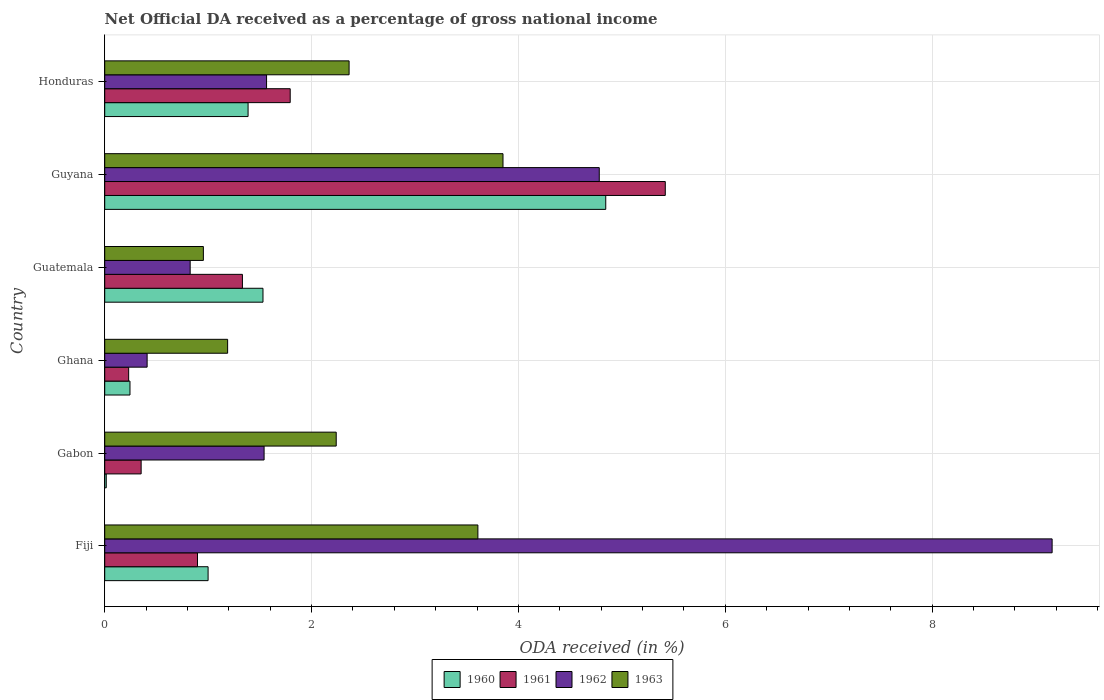How many groups of bars are there?
Offer a very short reply. 6. Are the number of bars per tick equal to the number of legend labels?
Give a very brief answer. Yes. Are the number of bars on each tick of the Y-axis equal?
Offer a very short reply. Yes. How many bars are there on the 5th tick from the top?
Give a very brief answer. 4. How many bars are there on the 2nd tick from the bottom?
Give a very brief answer. 4. What is the net official DA received in 1962 in Guyana?
Your answer should be compact. 4.78. Across all countries, what is the maximum net official DA received in 1963?
Your response must be concise. 3.85. Across all countries, what is the minimum net official DA received in 1962?
Keep it short and to the point. 0.41. In which country was the net official DA received in 1962 maximum?
Your answer should be compact. Fiji. In which country was the net official DA received in 1963 minimum?
Provide a succinct answer. Guatemala. What is the total net official DA received in 1963 in the graph?
Make the answer very short. 14.2. What is the difference between the net official DA received in 1960 in Gabon and that in Guatemala?
Your answer should be very brief. -1.52. What is the difference between the net official DA received in 1962 in Guyana and the net official DA received in 1961 in Honduras?
Give a very brief answer. 2.99. What is the average net official DA received in 1963 per country?
Offer a very short reply. 2.37. What is the difference between the net official DA received in 1962 and net official DA received in 1963 in Guyana?
Provide a short and direct response. 0.93. In how many countries, is the net official DA received in 1960 greater than 5.6 %?
Your answer should be compact. 0. What is the ratio of the net official DA received in 1963 in Gabon to that in Ghana?
Provide a succinct answer. 1.88. Is the net official DA received in 1963 in Guatemala less than that in Honduras?
Ensure brevity in your answer.  Yes. What is the difference between the highest and the second highest net official DA received in 1961?
Offer a terse response. 3.63. What is the difference between the highest and the lowest net official DA received in 1963?
Your answer should be very brief. 2.9. Is it the case that in every country, the sum of the net official DA received in 1962 and net official DA received in 1960 is greater than the sum of net official DA received in 1963 and net official DA received in 1961?
Your response must be concise. No. What does the 1st bar from the top in Guyana represents?
Your response must be concise. 1963. What does the 2nd bar from the bottom in Ghana represents?
Offer a terse response. 1961. Is it the case that in every country, the sum of the net official DA received in 1963 and net official DA received in 1960 is greater than the net official DA received in 1962?
Give a very brief answer. No. How many bars are there?
Provide a succinct answer. 24. How many legend labels are there?
Make the answer very short. 4. What is the title of the graph?
Provide a short and direct response. Net Official DA received as a percentage of gross national income. What is the label or title of the X-axis?
Keep it short and to the point. ODA received (in %). What is the ODA received (in %) in 1960 in Fiji?
Your answer should be compact. 1. What is the ODA received (in %) of 1961 in Fiji?
Make the answer very short. 0.9. What is the ODA received (in %) of 1962 in Fiji?
Offer a very short reply. 9.16. What is the ODA received (in %) in 1963 in Fiji?
Ensure brevity in your answer.  3.61. What is the ODA received (in %) in 1960 in Gabon?
Provide a succinct answer. 0.01. What is the ODA received (in %) of 1961 in Gabon?
Keep it short and to the point. 0.35. What is the ODA received (in %) of 1962 in Gabon?
Your response must be concise. 1.54. What is the ODA received (in %) in 1963 in Gabon?
Your answer should be compact. 2.24. What is the ODA received (in %) of 1960 in Ghana?
Your answer should be compact. 0.24. What is the ODA received (in %) in 1961 in Ghana?
Provide a short and direct response. 0.23. What is the ODA received (in %) in 1962 in Ghana?
Ensure brevity in your answer.  0.41. What is the ODA received (in %) in 1963 in Ghana?
Make the answer very short. 1.19. What is the ODA received (in %) of 1960 in Guatemala?
Provide a short and direct response. 1.53. What is the ODA received (in %) of 1961 in Guatemala?
Keep it short and to the point. 1.33. What is the ODA received (in %) in 1962 in Guatemala?
Your answer should be very brief. 0.83. What is the ODA received (in %) in 1963 in Guatemala?
Ensure brevity in your answer.  0.95. What is the ODA received (in %) in 1960 in Guyana?
Make the answer very short. 4.84. What is the ODA received (in %) of 1961 in Guyana?
Offer a very short reply. 5.42. What is the ODA received (in %) of 1962 in Guyana?
Your response must be concise. 4.78. What is the ODA received (in %) of 1963 in Guyana?
Your answer should be compact. 3.85. What is the ODA received (in %) in 1960 in Honduras?
Give a very brief answer. 1.39. What is the ODA received (in %) of 1961 in Honduras?
Keep it short and to the point. 1.79. What is the ODA received (in %) of 1962 in Honduras?
Give a very brief answer. 1.56. What is the ODA received (in %) in 1963 in Honduras?
Keep it short and to the point. 2.36. Across all countries, what is the maximum ODA received (in %) of 1960?
Offer a very short reply. 4.84. Across all countries, what is the maximum ODA received (in %) in 1961?
Provide a succinct answer. 5.42. Across all countries, what is the maximum ODA received (in %) in 1962?
Make the answer very short. 9.16. Across all countries, what is the maximum ODA received (in %) of 1963?
Ensure brevity in your answer.  3.85. Across all countries, what is the minimum ODA received (in %) in 1960?
Give a very brief answer. 0.01. Across all countries, what is the minimum ODA received (in %) of 1961?
Your response must be concise. 0.23. Across all countries, what is the minimum ODA received (in %) of 1962?
Make the answer very short. 0.41. Across all countries, what is the minimum ODA received (in %) in 1963?
Your answer should be compact. 0.95. What is the total ODA received (in %) of 1960 in the graph?
Make the answer very short. 9.02. What is the total ODA received (in %) in 1961 in the graph?
Your response must be concise. 10.03. What is the total ODA received (in %) of 1962 in the graph?
Your answer should be compact. 18.28. What is the total ODA received (in %) of 1963 in the graph?
Offer a very short reply. 14.2. What is the difference between the ODA received (in %) in 1960 in Fiji and that in Gabon?
Provide a short and direct response. 0.98. What is the difference between the ODA received (in %) of 1961 in Fiji and that in Gabon?
Provide a succinct answer. 0.55. What is the difference between the ODA received (in %) in 1962 in Fiji and that in Gabon?
Provide a succinct answer. 7.62. What is the difference between the ODA received (in %) of 1963 in Fiji and that in Gabon?
Offer a terse response. 1.37. What is the difference between the ODA received (in %) of 1960 in Fiji and that in Ghana?
Offer a very short reply. 0.76. What is the difference between the ODA received (in %) of 1961 in Fiji and that in Ghana?
Provide a succinct answer. 0.67. What is the difference between the ODA received (in %) of 1962 in Fiji and that in Ghana?
Provide a short and direct response. 8.75. What is the difference between the ODA received (in %) in 1963 in Fiji and that in Ghana?
Your answer should be compact. 2.42. What is the difference between the ODA received (in %) in 1960 in Fiji and that in Guatemala?
Provide a short and direct response. -0.53. What is the difference between the ODA received (in %) in 1961 in Fiji and that in Guatemala?
Make the answer very short. -0.43. What is the difference between the ODA received (in %) of 1962 in Fiji and that in Guatemala?
Offer a terse response. 8.33. What is the difference between the ODA received (in %) of 1963 in Fiji and that in Guatemala?
Your answer should be compact. 2.65. What is the difference between the ODA received (in %) in 1960 in Fiji and that in Guyana?
Offer a very short reply. -3.84. What is the difference between the ODA received (in %) of 1961 in Fiji and that in Guyana?
Provide a short and direct response. -4.52. What is the difference between the ODA received (in %) in 1962 in Fiji and that in Guyana?
Provide a short and direct response. 4.38. What is the difference between the ODA received (in %) of 1963 in Fiji and that in Guyana?
Offer a terse response. -0.24. What is the difference between the ODA received (in %) of 1960 in Fiji and that in Honduras?
Your answer should be compact. -0.39. What is the difference between the ODA received (in %) in 1961 in Fiji and that in Honduras?
Provide a short and direct response. -0.9. What is the difference between the ODA received (in %) in 1962 in Fiji and that in Honduras?
Offer a very short reply. 7.59. What is the difference between the ODA received (in %) in 1963 in Fiji and that in Honduras?
Your answer should be very brief. 1.25. What is the difference between the ODA received (in %) in 1960 in Gabon and that in Ghana?
Provide a short and direct response. -0.23. What is the difference between the ODA received (in %) in 1961 in Gabon and that in Ghana?
Your answer should be very brief. 0.12. What is the difference between the ODA received (in %) of 1962 in Gabon and that in Ghana?
Ensure brevity in your answer.  1.13. What is the difference between the ODA received (in %) of 1963 in Gabon and that in Ghana?
Give a very brief answer. 1.05. What is the difference between the ODA received (in %) of 1960 in Gabon and that in Guatemala?
Keep it short and to the point. -1.52. What is the difference between the ODA received (in %) of 1961 in Gabon and that in Guatemala?
Your answer should be very brief. -0.98. What is the difference between the ODA received (in %) in 1962 in Gabon and that in Guatemala?
Offer a very short reply. 0.71. What is the difference between the ODA received (in %) in 1963 in Gabon and that in Guatemala?
Provide a succinct answer. 1.28. What is the difference between the ODA received (in %) in 1960 in Gabon and that in Guyana?
Provide a short and direct response. -4.83. What is the difference between the ODA received (in %) in 1961 in Gabon and that in Guyana?
Your answer should be compact. -5.07. What is the difference between the ODA received (in %) in 1962 in Gabon and that in Guyana?
Your answer should be compact. -3.24. What is the difference between the ODA received (in %) of 1963 in Gabon and that in Guyana?
Keep it short and to the point. -1.61. What is the difference between the ODA received (in %) of 1960 in Gabon and that in Honduras?
Provide a succinct answer. -1.37. What is the difference between the ODA received (in %) of 1961 in Gabon and that in Honduras?
Offer a very short reply. -1.44. What is the difference between the ODA received (in %) in 1962 in Gabon and that in Honduras?
Provide a short and direct response. -0.02. What is the difference between the ODA received (in %) of 1963 in Gabon and that in Honduras?
Your response must be concise. -0.12. What is the difference between the ODA received (in %) of 1960 in Ghana and that in Guatemala?
Keep it short and to the point. -1.29. What is the difference between the ODA received (in %) in 1961 in Ghana and that in Guatemala?
Your answer should be very brief. -1.1. What is the difference between the ODA received (in %) in 1962 in Ghana and that in Guatemala?
Offer a very short reply. -0.42. What is the difference between the ODA received (in %) in 1963 in Ghana and that in Guatemala?
Keep it short and to the point. 0.23. What is the difference between the ODA received (in %) in 1960 in Ghana and that in Guyana?
Offer a terse response. -4.6. What is the difference between the ODA received (in %) of 1961 in Ghana and that in Guyana?
Provide a short and direct response. -5.19. What is the difference between the ODA received (in %) of 1962 in Ghana and that in Guyana?
Your response must be concise. -4.37. What is the difference between the ODA received (in %) of 1963 in Ghana and that in Guyana?
Keep it short and to the point. -2.66. What is the difference between the ODA received (in %) of 1960 in Ghana and that in Honduras?
Provide a succinct answer. -1.14. What is the difference between the ODA received (in %) of 1961 in Ghana and that in Honduras?
Keep it short and to the point. -1.56. What is the difference between the ODA received (in %) in 1962 in Ghana and that in Honduras?
Provide a succinct answer. -1.15. What is the difference between the ODA received (in %) of 1963 in Ghana and that in Honduras?
Give a very brief answer. -1.17. What is the difference between the ODA received (in %) of 1960 in Guatemala and that in Guyana?
Provide a succinct answer. -3.31. What is the difference between the ODA received (in %) in 1961 in Guatemala and that in Guyana?
Provide a succinct answer. -4.09. What is the difference between the ODA received (in %) of 1962 in Guatemala and that in Guyana?
Your answer should be compact. -3.96. What is the difference between the ODA received (in %) of 1963 in Guatemala and that in Guyana?
Offer a terse response. -2.9. What is the difference between the ODA received (in %) in 1960 in Guatemala and that in Honduras?
Your answer should be very brief. 0.14. What is the difference between the ODA received (in %) of 1961 in Guatemala and that in Honduras?
Your response must be concise. -0.46. What is the difference between the ODA received (in %) of 1962 in Guatemala and that in Honduras?
Offer a very short reply. -0.74. What is the difference between the ODA received (in %) in 1963 in Guatemala and that in Honduras?
Give a very brief answer. -1.41. What is the difference between the ODA received (in %) in 1960 in Guyana and that in Honduras?
Your answer should be very brief. 3.46. What is the difference between the ODA received (in %) in 1961 in Guyana and that in Honduras?
Ensure brevity in your answer.  3.63. What is the difference between the ODA received (in %) of 1962 in Guyana and that in Honduras?
Make the answer very short. 3.22. What is the difference between the ODA received (in %) in 1963 in Guyana and that in Honduras?
Your answer should be very brief. 1.49. What is the difference between the ODA received (in %) in 1960 in Fiji and the ODA received (in %) in 1961 in Gabon?
Your answer should be compact. 0.65. What is the difference between the ODA received (in %) in 1960 in Fiji and the ODA received (in %) in 1962 in Gabon?
Ensure brevity in your answer.  -0.54. What is the difference between the ODA received (in %) in 1960 in Fiji and the ODA received (in %) in 1963 in Gabon?
Your answer should be compact. -1.24. What is the difference between the ODA received (in %) in 1961 in Fiji and the ODA received (in %) in 1962 in Gabon?
Offer a very short reply. -0.64. What is the difference between the ODA received (in %) of 1961 in Fiji and the ODA received (in %) of 1963 in Gabon?
Provide a short and direct response. -1.34. What is the difference between the ODA received (in %) in 1962 in Fiji and the ODA received (in %) in 1963 in Gabon?
Ensure brevity in your answer.  6.92. What is the difference between the ODA received (in %) of 1960 in Fiji and the ODA received (in %) of 1961 in Ghana?
Make the answer very short. 0.77. What is the difference between the ODA received (in %) in 1960 in Fiji and the ODA received (in %) in 1962 in Ghana?
Give a very brief answer. 0.59. What is the difference between the ODA received (in %) of 1960 in Fiji and the ODA received (in %) of 1963 in Ghana?
Keep it short and to the point. -0.19. What is the difference between the ODA received (in %) of 1961 in Fiji and the ODA received (in %) of 1962 in Ghana?
Ensure brevity in your answer.  0.49. What is the difference between the ODA received (in %) of 1961 in Fiji and the ODA received (in %) of 1963 in Ghana?
Offer a terse response. -0.29. What is the difference between the ODA received (in %) of 1962 in Fiji and the ODA received (in %) of 1963 in Ghana?
Make the answer very short. 7.97. What is the difference between the ODA received (in %) in 1960 in Fiji and the ODA received (in %) in 1961 in Guatemala?
Keep it short and to the point. -0.33. What is the difference between the ODA received (in %) of 1960 in Fiji and the ODA received (in %) of 1962 in Guatemala?
Provide a succinct answer. 0.17. What is the difference between the ODA received (in %) in 1960 in Fiji and the ODA received (in %) in 1963 in Guatemala?
Offer a terse response. 0.05. What is the difference between the ODA received (in %) of 1961 in Fiji and the ODA received (in %) of 1962 in Guatemala?
Provide a short and direct response. 0.07. What is the difference between the ODA received (in %) of 1961 in Fiji and the ODA received (in %) of 1963 in Guatemala?
Your response must be concise. -0.06. What is the difference between the ODA received (in %) in 1962 in Fiji and the ODA received (in %) in 1963 in Guatemala?
Your answer should be compact. 8.21. What is the difference between the ODA received (in %) of 1960 in Fiji and the ODA received (in %) of 1961 in Guyana?
Offer a terse response. -4.42. What is the difference between the ODA received (in %) in 1960 in Fiji and the ODA received (in %) in 1962 in Guyana?
Provide a succinct answer. -3.78. What is the difference between the ODA received (in %) in 1960 in Fiji and the ODA received (in %) in 1963 in Guyana?
Provide a short and direct response. -2.85. What is the difference between the ODA received (in %) in 1961 in Fiji and the ODA received (in %) in 1962 in Guyana?
Your answer should be very brief. -3.88. What is the difference between the ODA received (in %) in 1961 in Fiji and the ODA received (in %) in 1963 in Guyana?
Give a very brief answer. -2.95. What is the difference between the ODA received (in %) of 1962 in Fiji and the ODA received (in %) of 1963 in Guyana?
Give a very brief answer. 5.31. What is the difference between the ODA received (in %) in 1960 in Fiji and the ODA received (in %) in 1961 in Honduras?
Make the answer very short. -0.79. What is the difference between the ODA received (in %) in 1960 in Fiji and the ODA received (in %) in 1962 in Honduras?
Offer a very short reply. -0.57. What is the difference between the ODA received (in %) in 1960 in Fiji and the ODA received (in %) in 1963 in Honduras?
Your answer should be very brief. -1.36. What is the difference between the ODA received (in %) of 1961 in Fiji and the ODA received (in %) of 1962 in Honduras?
Provide a short and direct response. -0.67. What is the difference between the ODA received (in %) in 1961 in Fiji and the ODA received (in %) in 1963 in Honduras?
Offer a terse response. -1.47. What is the difference between the ODA received (in %) in 1962 in Fiji and the ODA received (in %) in 1963 in Honduras?
Ensure brevity in your answer.  6.8. What is the difference between the ODA received (in %) in 1960 in Gabon and the ODA received (in %) in 1961 in Ghana?
Give a very brief answer. -0.22. What is the difference between the ODA received (in %) of 1960 in Gabon and the ODA received (in %) of 1962 in Ghana?
Offer a very short reply. -0.4. What is the difference between the ODA received (in %) of 1960 in Gabon and the ODA received (in %) of 1963 in Ghana?
Offer a terse response. -1.17. What is the difference between the ODA received (in %) of 1961 in Gabon and the ODA received (in %) of 1962 in Ghana?
Your answer should be very brief. -0.06. What is the difference between the ODA received (in %) in 1961 in Gabon and the ODA received (in %) in 1963 in Ghana?
Your answer should be very brief. -0.84. What is the difference between the ODA received (in %) in 1962 in Gabon and the ODA received (in %) in 1963 in Ghana?
Offer a very short reply. 0.35. What is the difference between the ODA received (in %) of 1960 in Gabon and the ODA received (in %) of 1961 in Guatemala?
Keep it short and to the point. -1.32. What is the difference between the ODA received (in %) of 1960 in Gabon and the ODA received (in %) of 1962 in Guatemala?
Offer a terse response. -0.81. What is the difference between the ODA received (in %) in 1960 in Gabon and the ODA received (in %) in 1963 in Guatemala?
Give a very brief answer. -0.94. What is the difference between the ODA received (in %) in 1961 in Gabon and the ODA received (in %) in 1962 in Guatemala?
Offer a terse response. -0.47. What is the difference between the ODA received (in %) in 1961 in Gabon and the ODA received (in %) in 1963 in Guatemala?
Provide a succinct answer. -0.6. What is the difference between the ODA received (in %) in 1962 in Gabon and the ODA received (in %) in 1963 in Guatemala?
Provide a succinct answer. 0.59. What is the difference between the ODA received (in %) in 1960 in Gabon and the ODA received (in %) in 1961 in Guyana?
Your answer should be very brief. -5.4. What is the difference between the ODA received (in %) of 1960 in Gabon and the ODA received (in %) of 1962 in Guyana?
Offer a terse response. -4.77. What is the difference between the ODA received (in %) in 1960 in Gabon and the ODA received (in %) in 1963 in Guyana?
Your answer should be compact. -3.84. What is the difference between the ODA received (in %) of 1961 in Gabon and the ODA received (in %) of 1962 in Guyana?
Provide a short and direct response. -4.43. What is the difference between the ODA received (in %) in 1961 in Gabon and the ODA received (in %) in 1963 in Guyana?
Keep it short and to the point. -3.5. What is the difference between the ODA received (in %) of 1962 in Gabon and the ODA received (in %) of 1963 in Guyana?
Offer a terse response. -2.31. What is the difference between the ODA received (in %) in 1960 in Gabon and the ODA received (in %) in 1961 in Honduras?
Ensure brevity in your answer.  -1.78. What is the difference between the ODA received (in %) of 1960 in Gabon and the ODA received (in %) of 1962 in Honduras?
Your answer should be compact. -1.55. What is the difference between the ODA received (in %) in 1960 in Gabon and the ODA received (in %) in 1963 in Honduras?
Offer a very short reply. -2.35. What is the difference between the ODA received (in %) in 1961 in Gabon and the ODA received (in %) in 1962 in Honduras?
Provide a succinct answer. -1.21. What is the difference between the ODA received (in %) of 1961 in Gabon and the ODA received (in %) of 1963 in Honduras?
Give a very brief answer. -2.01. What is the difference between the ODA received (in %) of 1962 in Gabon and the ODA received (in %) of 1963 in Honduras?
Offer a terse response. -0.82. What is the difference between the ODA received (in %) in 1960 in Ghana and the ODA received (in %) in 1961 in Guatemala?
Give a very brief answer. -1.09. What is the difference between the ODA received (in %) of 1960 in Ghana and the ODA received (in %) of 1962 in Guatemala?
Make the answer very short. -0.58. What is the difference between the ODA received (in %) of 1960 in Ghana and the ODA received (in %) of 1963 in Guatemala?
Offer a terse response. -0.71. What is the difference between the ODA received (in %) of 1961 in Ghana and the ODA received (in %) of 1962 in Guatemala?
Provide a short and direct response. -0.59. What is the difference between the ODA received (in %) of 1961 in Ghana and the ODA received (in %) of 1963 in Guatemala?
Offer a terse response. -0.72. What is the difference between the ODA received (in %) in 1962 in Ghana and the ODA received (in %) in 1963 in Guatemala?
Provide a succinct answer. -0.54. What is the difference between the ODA received (in %) in 1960 in Ghana and the ODA received (in %) in 1961 in Guyana?
Offer a terse response. -5.18. What is the difference between the ODA received (in %) in 1960 in Ghana and the ODA received (in %) in 1962 in Guyana?
Make the answer very short. -4.54. What is the difference between the ODA received (in %) in 1960 in Ghana and the ODA received (in %) in 1963 in Guyana?
Your answer should be compact. -3.61. What is the difference between the ODA received (in %) in 1961 in Ghana and the ODA received (in %) in 1962 in Guyana?
Your response must be concise. -4.55. What is the difference between the ODA received (in %) of 1961 in Ghana and the ODA received (in %) of 1963 in Guyana?
Provide a short and direct response. -3.62. What is the difference between the ODA received (in %) of 1962 in Ghana and the ODA received (in %) of 1963 in Guyana?
Your answer should be very brief. -3.44. What is the difference between the ODA received (in %) in 1960 in Ghana and the ODA received (in %) in 1961 in Honduras?
Make the answer very short. -1.55. What is the difference between the ODA received (in %) in 1960 in Ghana and the ODA received (in %) in 1962 in Honduras?
Keep it short and to the point. -1.32. What is the difference between the ODA received (in %) of 1960 in Ghana and the ODA received (in %) of 1963 in Honduras?
Your answer should be compact. -2.12. What is the difference between the ODA received (in %) in 1961 in Ghana and the ODA received (in %) in 1962 in Honduras?
Provide a short and direct response. -1.33. What is the difference between the ODA received (in %) of 1961 in Ghana and the ODA received (in %) of 1963 in Honduras?
Your answer should be very brief. -2.13. What is the difference between the ODA received (in %) in 1962 in Ghana and the ODA received (in %) in 1963 in Honduras?
Your answer should be compact. -1.95. What is the difference between the ODA received (in %) in 1960 in Guatemala and the ODA received (in %) in 1961 in Guyana?
Offer a terse response. -3.89. What is the difference between the ODA received (in %) in 1960 in Guatemala and the ODA received (in %) in 1962 in Guyana?
Your answer should be very brief. -3.25. What is the difference between the ODA received (in %) of 1960 in Guatemala and the ODA received (in %) of 1963 in Guyana?
Your response must be concise. -2.32. What is the difference between the ODA received (in %) of 1961 in Guatemala and the ODA received (in %) of 1962 in Guyana?
Provide a succinct answer. -3.45. What is the difference between the ODA received (in %) in 1961 in Guatemala and the ODA received (in %) in 1963 in Guyana?
Offer a terse response. -2.52. What is the difference between the ODA received (in %) in 1962 in Guatemala and the ODA received (in %) in 1963 in Guyana?
Your answer should be compact. -3.02. What is the difference between the ODA received (in %) of 1960 in Guatemala and the ODA received (in %) of 1961 in Honduras?
Ensure brevity in your answer.  -0.26. What is the difference between the ODA received (in %) in 1960 in Guatemala and the ODA received (in %) in 1962 in Honduras?
Keep it short and to the point. -0.03. What is the difference between the ODA received (in %) in 1960 in Guatemala and the ODA received (in %) in 1963 in Honduras?
Make the answer very short. -0.83. What is the difference between the ODA received (in %) in 1961 in Guatemala and the ODA received (in %) in 1962 in Honduras?
Offer a terse response. -0.23. What is the difference between the ODA received (in %) of 1961 in Guatemala and the ODA received (in %) of 1963 in Honduras?
Provide a short and direct response. -1.03. What is the difference between the ODA received (in %) in 1962 in Guatemala and the ODA received (in %) in 1963 in Honduras?
Your response must be concise. -1.54. What is the difference between the ODA received (in %) of 1960 in Guyana and the ODA received (in %) of 1961 in Honduras?
Provide a short and direct response. 3.05. What is the difference between the ODA received (in %) in 1960 in Guyana and the ODA received (in %) in 1962 in Honduras?
Provide a short and direct response. 3.28. What is the difference between the ODA received (in %) in 1960 in Guyana and the ODA received (in %) in 1963 in Honduras?
Your answer should be very brief. 2.48. What is the difference between the ODA received (in %) in 1961 in Guyana and the ODA received (in %) in 1962 in Honduras?
Offer a very short reply. 3.85. What is the difference between the ODA received (in %) in 1961 in Guyana and the ODA received (in %) in 1963 in Honduras?
Your answer should be compact. 3.06. What is the difference between the ODA received (in %) of 1962 in Guyana and the ODA received (in %) of 1963 in Honduras?
Keep it short and to the point. 2.42. What is the average ODA received (in %) of 1960 per country?
Offer a very short reply. 1.5. What is the average ODA received (in %) in 1961 per country?
Your answer should be compact. 1.67. What is the average ODA received (in %) of 1962 per country?
Your answer should be compact. 3.05. What is the average ODA received (in %) of 1963 per country?
Make the answer very short. 2.37. What is the difference between the ODA received (in %) in 1960 and ODA received (in %) in 1961 in Fiji?
Ensure brevity in your answer.  0.1. What is the difference between the ODA received (in %) in 1960 and ODA received (in %) in 1962 in Fiji?
Offer a terse response. -8.16. What is the difference between the ODA received (in %) in 1960 and ODA received (in %) in 1963 in Fiji?
Your response must be concise. -2.61. What is the difference between the ODA received (in %) of 1961 and ODA received (in %) of 1962 in Fiji?
Offer a very short reply. -8.26. What is the difference between the ODA received (in %) of 1961 and ODA received (in %) of 1963 in Fiji?
Your response must be concise. -2.71. What is the difference between the ODA received (in %) in 1962 and ODA received (in %) in 1963 in Fiji?
Your response must be concise. 5.55. What is the difference between the ODA received (in %) in 1960 and ODA received (in %) in 1961 in Gabon?
Give a very brief answer. -0.34. What is the difference between the ODA received (in %) of 1960 and ODA received (in %) of 1962 in Gabon?
Provide a short and direct response. -1.53. What is the difference between the ODA received (in %) in 1960 and ODA received (in %) in 1963 in Gabon?
Make the answer very short. -2.22. What is the difference between the ODA received (in %) in 1961 and ODA received (in %) in 1962 in Gabon?
Make the answer very short. -1.19. What is the difference between the ODA received (in %) of 1961 and ODA received (in %) of 1963 in Gabon?
Your answer should be compact. -1.89. What is the difference between the ODA received (in %) of 1962 and ODA received (in %) of 1963 in Gabon?
Offer a terse response. -0.7. What is the difference between the ODA received (in %) of 1960 and ODA received (in %) of 1961 in Ghana?
Ensure brevity in your answer.  0.01. What is the difference between the ODA received (in %) of 1960 and ODA received (in %) of 1962 in Ghana?
Make the answer very short. -0.17. What is the difference between the ODA received (in %) in 1960 and ODA received (in %) in 1963 in Ghana?
Your answer should be very brief. -0.94. What is the difference between the ODA received (in %) in 1961 and ODA received (in %) in 1962 in Ghana?
Make the answer very short. -0.18. What is the difference between the ODA received (in %) of 1961 and ODA received (in %) of 1963 in Ghana?
Offer a terse response. -0.96. What is the difference between the ODA received (in %) in 1962 and ODA received (in %) in 1963 in Ghana?
Offer a terse response. -0.78. What is the difference between the ODA received (in %) in 1960 and ODA received (in %) in 1961 in Guatemala?
Offer a very short reply. 0.2. What is the difference between the ODA received (in %) in 1960 and ODA received (in %) in 1962 in Guatemala?
Keep it short and to the point. 0.7. What is the difference between the ODA received (in %) in 1960 and ODA received (in %) in 1963 in Guatemala?
Your answer should be compact. 0.58. What is the difference between the ODA received (in %) in 1961 and ODA received (in %) in 1962 in Guatemala?
Provide a short and direct response. 0.51. What is the difference between the ODA received (in %) in 1961 and ODA received (in %) in 1963 in Guatemala?
Make the answer very short. 0.38. What is the difference between the ODA received (in %) of 1962 and ODA received (in %) of 1963 in Guatemala?
Your answer should be compact. -0.13. What is the difference between the ODA received (in %) of 1960 and ODA received (in %) of 1961 in Guyana?
Your response must be concise. -0.58. What is the difference between the ODA received (in %) in 1960 and ODA received (in %) in 1962 in Guyana?
Ensure brevity in your answer.  0.06. What is the difference between the ODA received (in %) of 1960 and ODA received (in %) of 1963 in Guyana?
Offer a very short reply. 0.99. What is the difference between the ODA received (in %) of 1961 and ODA received (in %) of 1962 in Guyana?
Provide a succinct answer. 0.64. What is the difference between the ODA received (in %) in 1961 and ODA received (in %) in 1963 in Guyana?
Provide a short and direct response. 1.57. What is the difference between the ODA received (in %) of 1962 and ODA received (in %) of 1963 in Guyana?
Your answer should be very brief. 0.93. What is the difference between the ODA received (in %) in 1960 and ODA received (in %) in 1961 in Honduras?
Your answer should be very brief. -0.41. What is the difference between the ODA received (in %) in 1960 and ODA received (in %) in 1962 in Honduras?
Provide a succinct answer. -0.18. What is the difference between the ODA received (in %) of 1960 and ODA received (in %) of 1963 in Honduras?
Your response must be concise. -0.98. What is the difference between the ODA received (in %) in 1961 and ODA received (in %) in 1962 in Honduras?
Keep it short and to the point. 0.23. What is the difference between the ODA received (in %) in 1961 and ODA received (in %) in 1963 in Honduras?
Your response must be concise. -0.57. What is the difference between the ODA received (in %) in 1962 and ODA received (in %) in 1963 in Honduras?
Ensure brevity in your answer.  -0.8. What is the ratio of the ODA received (in %) of 1960 in Fiji to that in Gabon?
Give a very brief answer. 67.36. What is the ratio of the ODA received (in %) of 1961 in Fiji to that in Gabon?
Keep it short and to the point. 2.55. What is the ratio of the ODA received (in %) in 1962 in Fiji to that in Gabon?
Offer a very short reply. 5.94. What is the ratio of the ODA received (in %) of 1963 in Fiji to that in Gabon?
Provide a succinct answer. 1.61. What is the ratio of the ODA received (in %) of 1960 in Fiji to that in Ghana?
Ensure brevity in your answer.  4.09. What is the ratio of the ODA received (in %) of 1961 in Fiji to that in Ghana?
Offer a very short reply. 3.88. What is the ratio of the ODA received (in %) in 1962 in Fiji to that in Ghana?
Your response must be concise. 22.34. What is the ratio of the ODA received (in %) of 1963 in Fiji to that in Ghana?
Provide a succinct answer. 3.04. What is the ratio of the ODA received (in %) of 1960 in Fiji to that in Guatemala?
Provide a short and direct response. 0.65. What is the ratio of the ODA received (in %) in 1961 in Fiji to that in Guatemala?
Your answer should be very brief. 0.67. What is the ratio of the ODA received (in %) of 1962 in Fiji to that in Guatemala?
Give a very brief answer. 11.09. What is the ratio of the ODA received (in %) of 1963 in Fiji to that in Guatemala?
Make the answer very short. 3.78. What is the ratio of the ODA received (in %) of 1960 in Fiji to that in Guyana?
Ensure brevity in your answer.  0.21. What is the ratio of the ODA received (in %) in 1961 in Fiji to that in Guyana?
Provide a short and direct response. 0.17. What is the ratio of the ODA received (in %) in 1962 in Fiji to that in Guyana?
Provide a succinct answer. 1.92. What is the ratio of the ODA received (in %) in 1963 in Fiji to that in Guyana?
Your answer should be compact. 0.94. What is the ratio of the ODA received (in %) of 1960 in Fiji to that in Honduras?
Offer a terse response. 0.72. What is the ratio of the ODA received (in %) of 1961 in Fiji to that in Honduras?
Offer a terse response. 0.5. What is the ratio of the ODA received (in %) of 1962 in Fiji to that in Honduras?
Your response must be concise. 5.85. What is the ratio of the ODA received (in %) in 1963 in Fiji to that in Honduras?
Keep it short and to the point. 1.53. What is the ratio of the ODA received (in %) in 1960 in Gabon to that in Ghana?
Give a very brief answer. 0.06. What is the ratio of the ODA received (in %) in 1961 in Gabon to that in Ghana?
Provide a short and direct response. 1.52. What is the ratio of the ODA received (in %) of 1962 in Gabon to that in Ghana?
Your response must be concise. 3.76. What is the ratio of the ODA received (in %) in 1963 in Gabon to that in Ghana?
Give a very brief answer. 1.88. What is the ratio of the ODA received (in %) of 1960 in Gabon to that in Guatemala?
Your answer should be compact. 0.01. What is the ratio of the ODA received (in %) of 1961 in Gabon to that in Guatemala?
Make the answer very short. 0.26. What is the ratio of the ODA received (in %) in 1962 in Gabon to that in Guatemala?
Provide a succinct answer. 1.86. What is the ratio of the ODA received (in %) of 1963 in Gabon to that in Guatemala?
Give a very brief answer. 2.35. What is the ratio of the ODA received (in %) of 1960 in Gabon to that in Guyana?
Your answer should be compact. 0. What is the ratio of the ODA received (in %) in 1961 in Gabon to that in Guyana?
Make the answer very short. 0.07. What is the ratio of the ODA received (in %) in 1962 in Gabon to that in Guyana?
Provide a succinct answer. 0.32. What is the ratio of the ODA received (in %) of 1963 in Gabon to that in Guyana?
Give a very brief answer. 0.58. What is the ratio of the ODA received (in %) in 1960 in Gabon to that in Honduras?
Keep it short and to the point. 0.01. What is the ratio of the ODA received (in %) of 1961 in Gabon to that in Honduras?
Provide a succinct answer. 0.2. What is the ratio of the ODA received (in %) in 1962 in Gabon to that in Honduras?
Provide a short and direct response. 0.98. What is the ratio of the ODA received (in %) of 1963 in Gabon to that in Honduras?
Your answer should be compact. 0.95. What is the ratio of the ODA received (in %) of 1960 in Ghana to that in Guatemala?
Your response must be concise. 0.16. What is the ratio of the ODA received (in %) in 1961 in Ghana to that in Guatemala?
Your answer should be very brief. 0.17. What is the ratio of the ODA received (in %) in 1962 in Ghana to that in Guatemala?
Your answer should be compact. 0.5. What is the ratio of the ODA received (in %) in 1963 in Ghana to that in Guatemala?
Provide a short and direct response. 1.25. What is the ratio of the ODA received (in %) of 1960 in Ghana to that in Guyana?
Offer a very short reply. 0.05. What is the ratio of the ODA received (in %) in 1961 in Ghana to that in Guyana?
Your answer should be very brief. 0.04. What is the ratio of the ODA received (in %) of 1962 in Ghana to that in Guyana?
Your answer should be compact. 0.09. What is the ratio of the ODA received (in %) in 1963 in Ghana to that in Guyana?
Provide a succinct answer. 0.31. What is the ratio of the ODA received (in %) of 1960 in Ghana to that in Honduras?
Your response must be concise. 0.18. What is the ratio of the ODA received (in %) of 1961 in Ghana to that in Honduras?
Provide a succinct answer. 0.13. What is the ratio of the ODA received (in %) of 1962 in Ghana to that in Honduras?
Keep it short and to the point. 0.26. What is the ratio of the ODA received (in %) of 1963 in Ghana to that in Honduras?
Offer a very short reply. 0.5. What is the ratio of the ODA received (in %) of 1960 in Guatemala to that in Guyana?
Offer a very short reply. 0.32. What is the ratio of the ODA received (in %) in 1961 in Guatemala to that in Guyana?
Your answer should be very brief. 0.25. What is the ratio of the ODA received (in %) of 1962 in Guatemala to that in Guyana?
Give a very brief answer. 0.17. What is the ratio of the ODA received (in %) of 1963 in Guatemala to that in Guyana?
Your answer should be compact. 0.25. What is the ratio of the ODA received (in %) of 1960 in Guatemala to that in Honduras?
Provide a short and direct response. 1.1. What is the ratio of the ODA received (in %) in 1961 in Guatemala to that in Honduras?
Give a very brief answer. 0.74. What is the ratio of the ODA received (in %) in 1962 in Guatemala to that in Honduras?
Your answer should be compact. 0.53. What is the ratio of the ODA received (in %) in 1963 in Guatemala to that in Honduras?
Provide a succinct answer. 0.4. What is the ratio of the ODA received (in %) in 1960 in Guyana to that in Honduras?
Ensure brevity in your answer.  3.49. What is the ratio of the ODA received (in %) in 1961 in Guyana to that in Honduras?
Offer a terse response. 3.02. What is the ratio of the ODA received (in %) of 1962 in Guyana to that in Honduras?
Provide a short and direct response. 3.06. What is the ratio of the ODA received (in %) in 1963 in Guyana to that in Honduras?
Give a very brief answer. 1.63. What is the difference between the highest and the second highest ODA received (in %) in 1960?
Your answer should be very brief. 3.31. What is the difference between the highest and the second highest ODA received (in %) of 1961?
Your answer should be very brief. 3.63. What is the difference between the highest and the second highest ODA received (in %) in 1962?
Provide a succinct answer. 4.38. What is the difference between the highest and the second highest ODA received (in %) of 1963?
Your answer should be compact. 0.24. What is the difference between the highest and the lowest ODA received (in %) in 1960?
Offer a very short reply. 4.83. What is the difference between the highest and the lowest ODA received (in %) in 1961?
Your answer should be compact. 5.19. What is the difference between the highest and the lowest ODA received (in %) of 1962?
Your response must be concise. 8.75. What is the difference between the highest and the lowest ODA received (in %) of 1963?
Give a very brief answer. 2.9. 